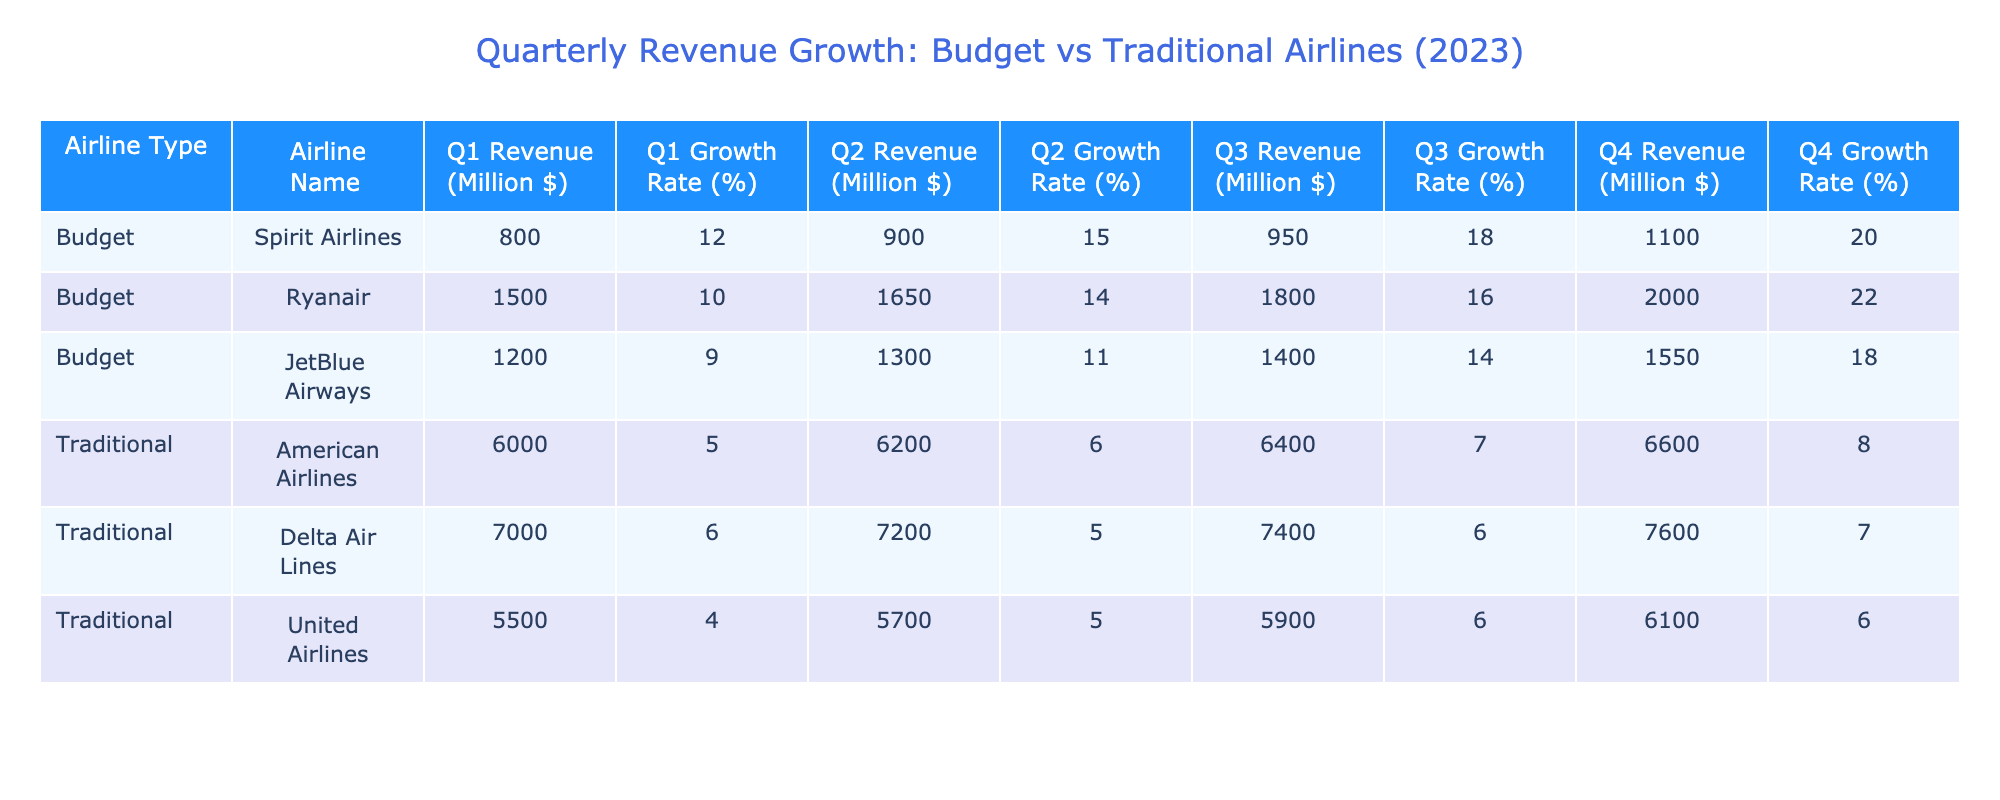What is the Q1 Revenue of Ryanair? Ryanair's Q1 Revenue is provided in the table under the Budget category. It shows a revenue value of 1500 million dollars.
Answer: 1500 million dollars Which budget airline had the highest Q4 growth rate? To determine the highest Q4 growth rate among budget airlines, we check the Q4 Growth Rate column for all budget airlines. Spirit Airlines had a growth rate of 20%, Ryanair had 22%, and JetBlue Airways had 18%. The highest is 22% for Ryanair.
Answer: 22% What is the average Q2 Revenue of traditional airlines? We sum the Q2 Revenue values for all traditional airlines: American Airlines (6200) + Delta Air Lines (7200) + United Airlines (5700) = 19100. There are 3 airlines, so the average Q2 Revenue is 19100 / 3 = 6366.67 million dollars.
Answer: 6366.67 million dollars Did Spirit Airlines experience a decline in revenue at any quarter in 2023? We need to check the Revenue values for Spirit Airlines across all quarters. The values are Q1: 800, Q2: 900, Q3: 950, Q4: 1100. Since all values are increasing over the quarters, there was no decline.
Answer: No Which type of airline (Budget or Traditional) had a higher total revenue for Q3? We add the Q3 Revenues for budget and traditional airlines. Budget: Spirit Airlines (950) + Ryanair (1800) + JetBlue Airways (1400) = 4150 million dollars. Traditional: American Airlines (6400) + Delta Air Lines (7400) + United Airlines (5900) = 19700 million dollars. So traditional airlines had higher total revenue for Q3.
Answer: Traditional airlines Which budget airline had the lowest Q1 Growth Rate? We check the Q1 Growth Rates for budget airlines: Spirit Airlines (12%), Ryanair (10%), and JetBlue Airways (9%). JetBlue Airways has the lowest growth rate at 9%.
Answer: 9% What was the total revenue for Ryanair across all quarters? We add Ryanair’s revenue from all quarters: Q1 (1500) + Q2 (1650) + Q3 (1800) + Q4 (2000) = 6950 million dollars.
Answer: 6950 million dollars Is the average Q1 Growth Rate of budget airlines higher than that of traditional airlines? The average Q1 Growth Rate for budget airlines is (12% + 10% + 9%) / 3 = 10.33%. For traditional airlines, it’s (5% + 6% + 4%) / 3 = 5%. Since 10.33% is higher than 5%, the statement is true.
Answer: Yes 